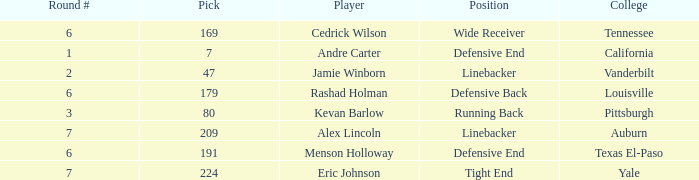Which pick came from Texas El-Paso? 191.0. 